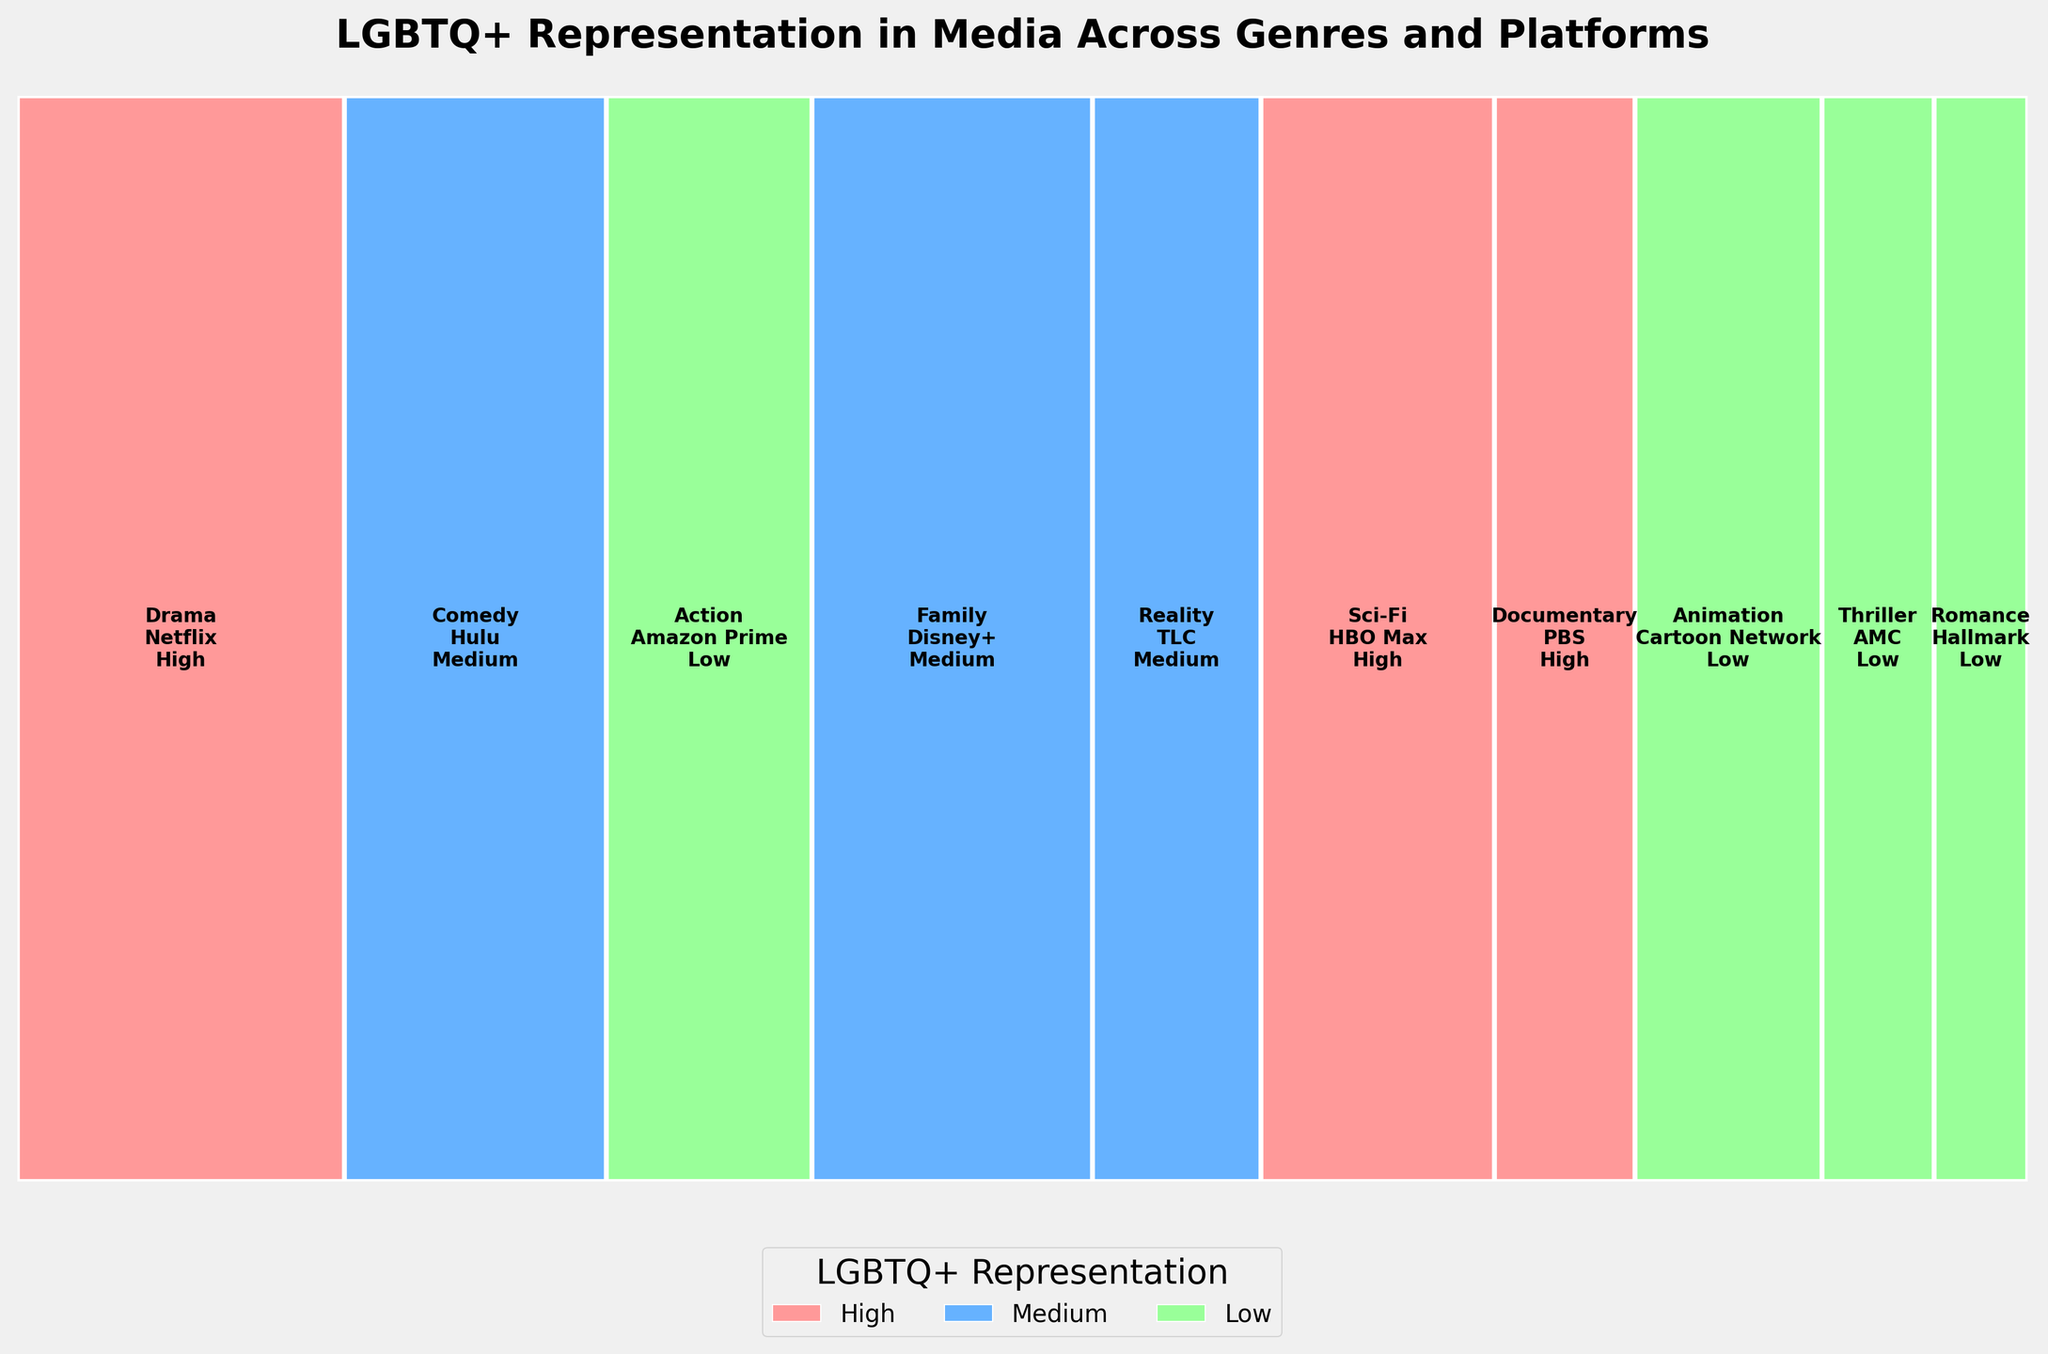What's the title of the plot? The title is typically located at the top center of the plot and summarizes the primary focus of the visualization.
Answer: LGBTQ+ Representation in Media Across Genres and Platforms What color represents 'High' LGBTQ+ representation in the plot? Each level of LGBTQ+ representation is assigned a specific color. By looking at the colors in the plot and matching them to the legend, we can determine that 'High' representation is shown in light red.
Answer: Light red Which genre and platform have the highest viewership in high LGBTQ+ representation? We need to identify the genres and platforms marked with 'High' representation and compare their viewership sizes. Using the plot, 'Drama' on Netflix has the largest section under 'High' representation.
Answer: Drama on Netflix How does the viewership of 'Family' on Disney+ compare to 'Reality' on TLC? Locate both 'Family' on Disney+ and 'Reality' on TLC in the plot, and compare the width of their corresponding rectangles. 'Family' on Disney+ has a larger viewership.
Answer: Family on Disney+ has higher viewership Are there more genres with 'Medium' or 'Low' LGBTQ+ representation? Count the number of rectangles labeled 'Medium' and 'Low' within the plot.
Answer: More genres with 'Low' LGBTQ+ representation What's the sum of viewership for genres with 'Medium' LGBTQ+ representation? Identify the genres marked with 'Medium' representation and sum their viewership: Comedy (28) + Family (30) + Reality (18).
Answer: 76 What's the difference in viewership between genres with 'High' and 'Low' LGBTQ+ representation? Sum the viewership for 'High' (Drama 35 + Sci-Fi 25 + Documentary 15) and 'Low' (Action 22 + Animation 20 + Thriller 12 + Romance 10) groups and find the difference: (75 - 64) = 11.
Answer: 11 Which platform has the lowest viewership for genres with 'Low' LGBTQ+ representation? Identify platforms in the 'Low' representation group and compare viewership. 'Romance' on Hallmark has the lowest viewership.
Answer: Hallmark Does 'Sci-Fi' on HBO Max have higher viewership than 'Documentary' on PBS? Directly compare the rectangles labeled 'Sci-Fi' on HBO Max and 'Documentary' on PBS and their respective sizes. 'Sci-Fi' has a higher viewership.
Answer: Yes What's the proportion of viewership for 'Animation' on Cartoon Network out of the total viewership? Calculate the viewership proportion: 20 (Animation) out of 215 (total viewership). 20/215 = 0.093 (approx)
Answer: Approximately 9.3% 